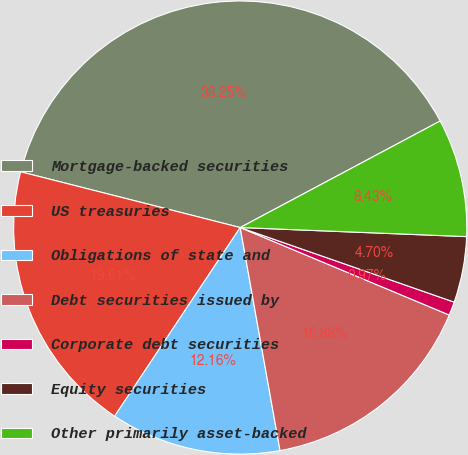Convert chart. <chart><loc_0><loc_0><loc_500><loc_500><pie_chart><fcel>Mortgage-backed securities<fcel>US treasuries<fcel>Obligations of state and<fcel>Debt securities issued by<fcel>Corporate debt securities<fcel>Equity securities<fcel>Other primarily asset-backed<nl><fcel>38.25%<fcel>19.61%<fcel>12.16%<fcel>15.88%<fcel>0.97%<fcel>4.7%<fcel>8.43%<nl></chart> 